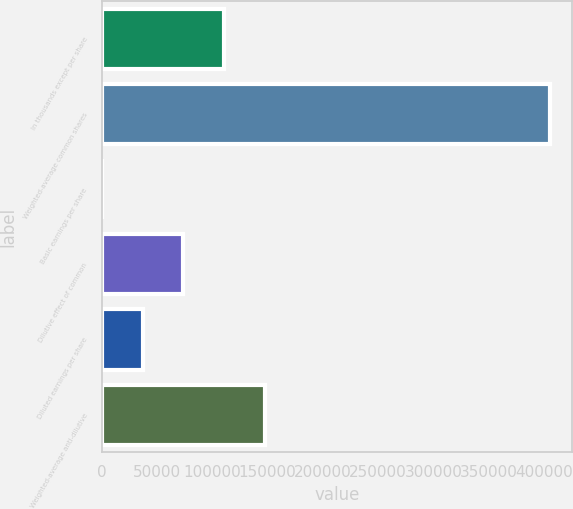Convert chart. <chart><loc_0><loc_0><loc_500><loc_500><bar_chart><fcel>In thousands except per share<fcel>Weighted-average common shares<fcel>Basic earnings per share<fcel>Dilutive effect of common<fcel>Diluted earnings per share<fcel>Weighted-average anti-dilutive<nl><fcel>110859<fcel>405373<fcel>1.56<fcel>73906.8<fcel>36954.2<fcel>147812<nl></chart> 